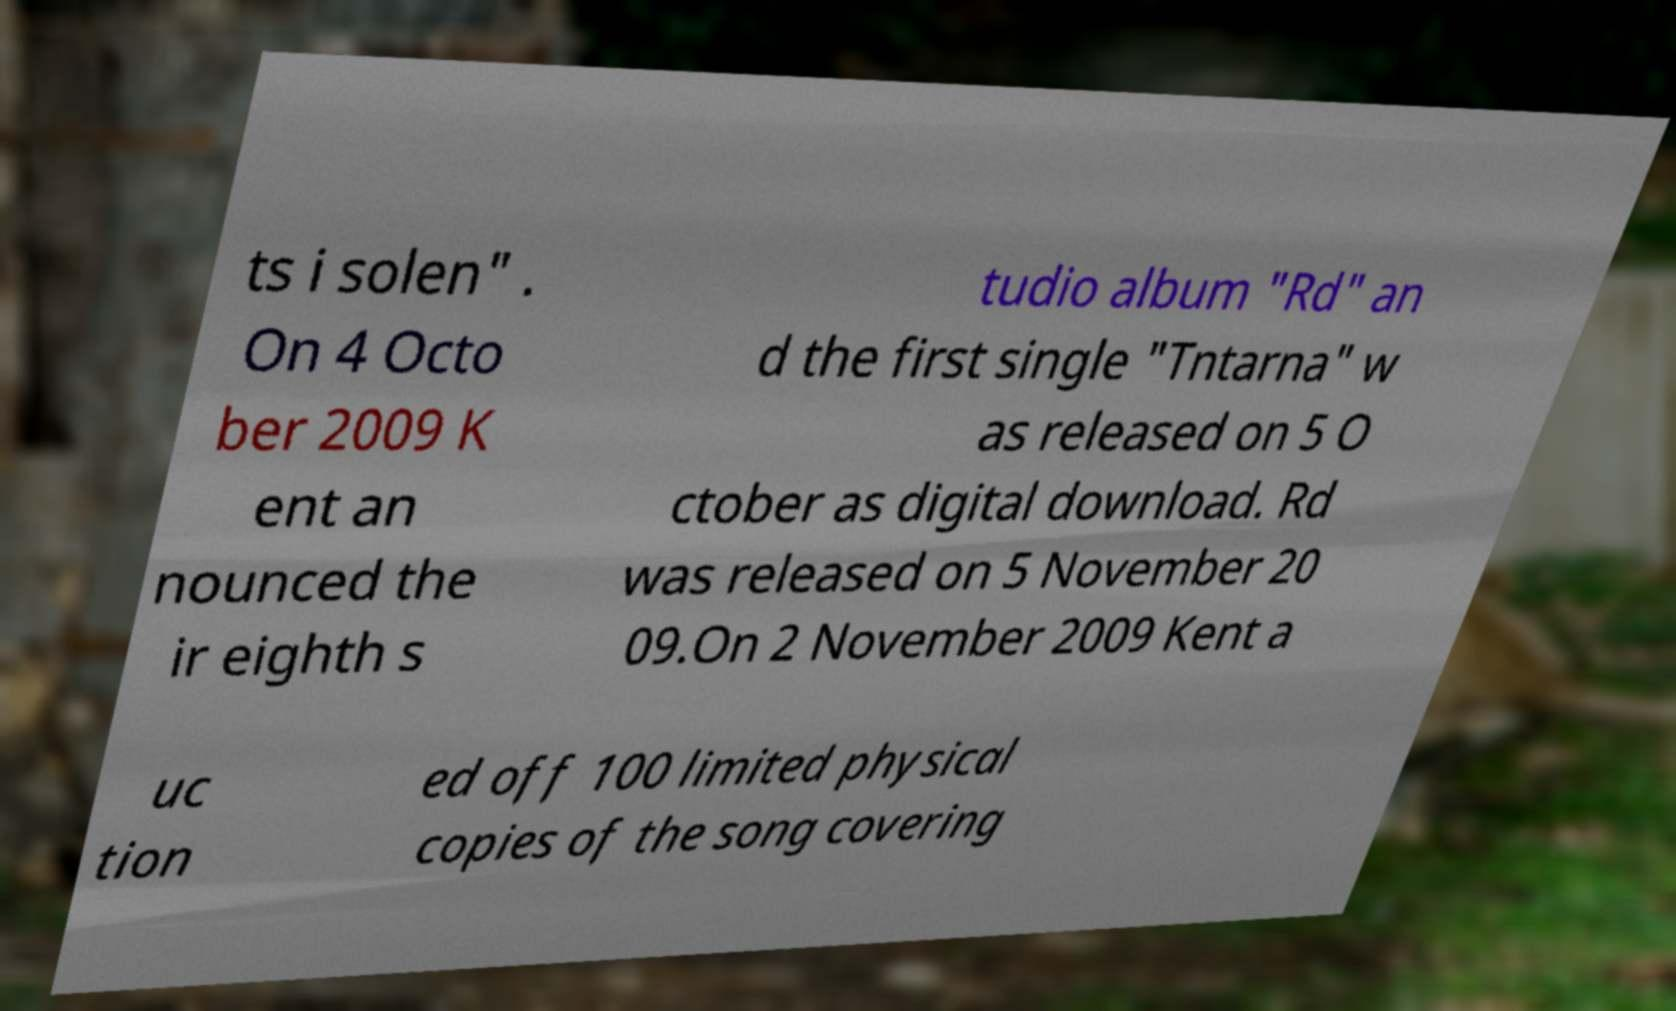Please identify and transcribe the text found in this image. ts i solen" . On 4 Octo ber 2009 K ent an nounced the ir eighth s tudio album "Rd" an d the first single "Tntarna" w as released on 5 O ctober as digital download. Rd was released on 5 November 20 09.On 2 November 2009 Kent a uc tion ed off 100 limited physical copies of the song covering 